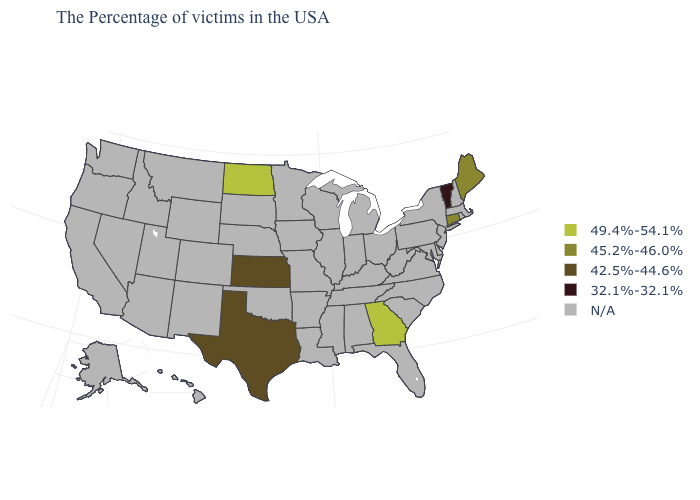Name the states that have a value in the range N/A?
Concise answer only. Massachusetts, Rhode Island, New Hampshire, New York, New Jersey, Delaware, Maryland, Pennsylvania, Virginia, North Carolina, South Carolina, West Virginia, Ohio, Florida, Michigan, Kentucky, Indiana, Alabama, Tennessee, Wisconsin, Illinois, Mississippi, Louisiana, Missouri, Arkansas, Minnesota, Iowa, Nebraska, Oklahoma, South Dakota, Wyoming, Colorado, New Mexico, Utah, Montana, Arizona, Idaho, Nevada, California, Washington, Oregon, Alaska, Hawaii. What is the value of Minnesota?
Answer briefly. N/A. What is the value of Louisiana?
Be succinct. N/A. Does the map have missing data?
Short answer required. Yes. Which states have the lowest value in the MidWest?
Answer briefly. Kansas. What is the value of Nevada?
Answer briefly. N/A. Name the states that have a value in the range 49.4%-54.1%?
Concise answer only. Georgia, North Dakota. Is the legend a continuous bar?
Give a very brief answer. No. How many symbols are there in the legend?
Concise answer only. 5. What is the value of New Jersey?
Give a very brief answer. N/A. Name the states that have a value in the range 49.4%-54.1%?
Answer briefly. Georgia, North Dakota. What is the value of Minnesota?
Answer briefly. N/A. 